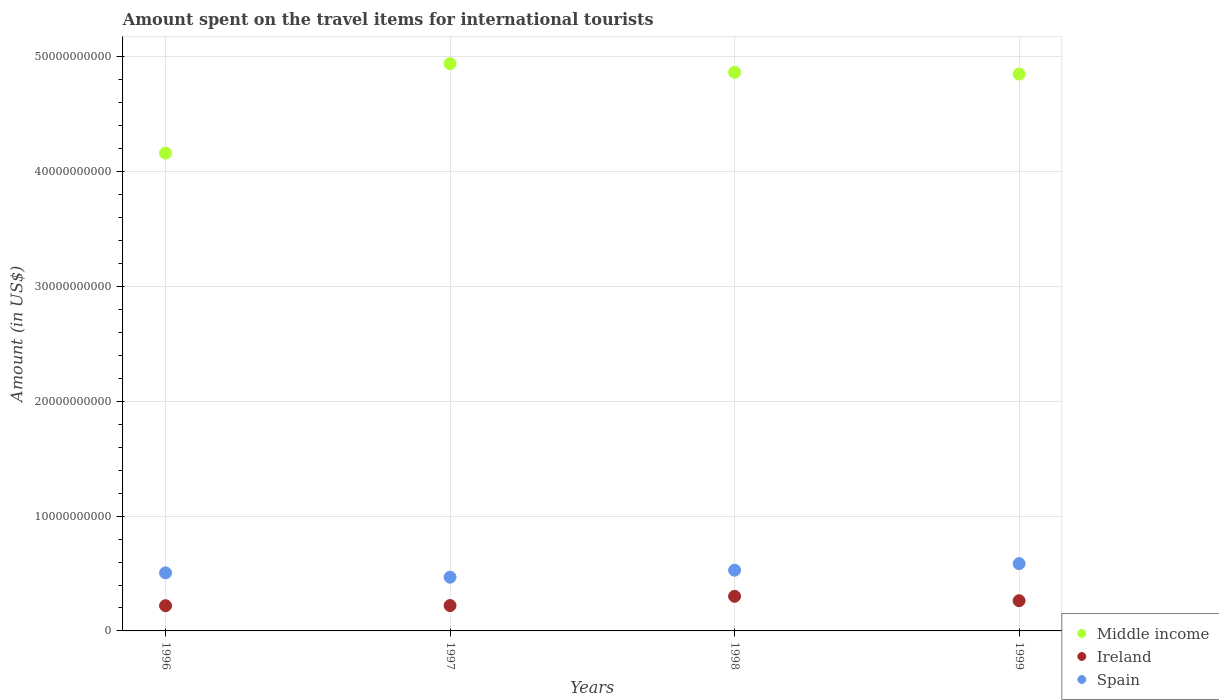What is the amount spent on the travel items for international tourists in Ireland in 1999?
Keep it short and to the point. 2.63e+09. Across all years, what is the maximum amount spent on the travel items for international tourists in Middle income?
Make the answer very short. 4.94e+1. Across all years, what is the minimum amount spent on the travel items for international tourists in Spain?
Give a very brief answer. 4.68e+09. In which year was the amount spent on the travel items for international tourists in Middle income maximum?
Give a very brief answer. 1997. In which year was the amount spent on the travel items for international tourists in Ireland minimum?
Offer a terse response. 1996. What is the total amount spent on the travel items for international tourists in Ireland in the graph?
Your answer should be compact. 1.01e+1. What is the difference between the amount spent on the travel items for international tourists in Ireland in 1997 and that in 1999?
Provide a succinct answer. -4.21e+08. What is the difference between the amount spent on the travel items for international tourists in Ireland in 1997 and the amount spent on the travel items for international tourists in Spain in 1999?
Your answer should be compact. -3.65e+09. What is the average amount spent on the travel items for international tourists in Spain per year?
Ensure brevity in your answer.  5.22e+09. In the year 1999, what is the difference between the amount spent on the travel items for international tourists in Middle income and amount spent on the travel items for international tourists in Spain?
Offer a terse response. 4.26e+1. In how many years, is the amount spent on the travel items for international tourists in Spain greater than 32000000000 US$?
Your response must be concise. 0. What is the ratio of the amount spent on the travel items for international tourists in Ireland in 1997 to that in 1998?
Your response must be concise. 0.73. Is the amount spent on the travel items for international tourists in Ireland in 1996 less than that in 1998?
Give a very brief answer. Yes. Is the difference between the amount spent on the travel items for international tourists in Middle income in 1997 and 1999 greater than the difference between the amount spent on the travel items for international tourists in Spain in 1997 and 1999?
Keep it short and to the point. Yes. What is the difference between the highest and the second highest amount spent on the travel items for international tourists in Spain?
Your answer should be compact. 5.74e+08. What is the difference between the highest and the lowest amount spent on the travel items for international tourists in Spain?
Keep it short and to the point. 1.18e+09. In how many years, is the amount spent on the travel items for international tourists in Middle income greater than the average amount spent on the travel items for international tourists in Middle income taken over all years?
Your answer should be compact. 3. How many years are there in the graph?
Provide a short and direct response. 4. What is the difference between two consecutive major ticks on the Y-axis?
Your answer should be very brief. 1.00e+1. Are the values on the major ticks of Y-axis written in scientific E-notation?
Your answer should be very brief. No. Does the graph contain any zero values?
Make the answer very short. No. Where does the legend appear in the graph?
Provide a short and direct response. Bottom right. How many legend labels are there?
Keep it short and to the point. 3. How are the legend labels stacked?
Your answer should be compact. Vertical. What is the title of the graph?
Keep it short and to the point. Amount spent on the travel items for international tourists. What is the label or title of the X-axis?
Offer a terse response. Years. What is the Amount (in US$) in Middle income in 1996?
Provide a succinct answer. 4.16e+1. What is the Amount (in US$) in Ireland in 1996?
Keep it short and to the point. 2.20e+09. What is the Amount (in US$) of Spain in 1996?
Make the answer very short. 5.06e+09. What is the Amount (in US$) of Middle income in 1997?
Make the answer very short. 4.94e+1. What is the Amount (in US$) of Ireland in 1997?
Your answer should be very brief. 2.21e+09. What is the Amount (in US$) of Spain in 1997?
Offer a terse response. 4.68e+09. What is the Amount (in US$) of Middle income in 1998?
Your response must be concise. 4.87e+1. What is the Amount (in US$) of Ireland in 1998?
Provide a succinct answer. 3.02e+09. What is the Amount (in US$) in Spain in 1998?
Your response must be concise. 5.29e+09. What is the Amount (in US$) of Middle income in 1999?
Your answer should be compact. 4.85e+1. What is the Amount (in US$) in Ireland in 1999?
Your answer should be compact. 2.63e+09. What is the Amount (in US$) of Spain in 1999?
Your answer should be compact. 5.86e+09. Across all years, what is the maximum Amount (in US$) of Middle income?
Give a very brief answer. 4.94e+1. Across all years, what is the maximum Amount (in US$) of Ireland?
Offer a terse response. 3.02e+09. Across all years, what is the maximum Amount (in US$) in Spain?
Provide a succinct answer. 5.86e+09. Across all years, what is the minimum Amount (in US$) in Middle income?
Your answer should be compact. 4.16e+1. Across all years, what is the minimum Amount (in US$) in Ireland?
Give a very brief answer. 2.20e+09. Across all years, what is the minimum Amount (in US$) in Spain?
Give a very brief answer. 4.68e+09. What is the total Amount (in US$) of Middle income in the graph?
Ensure brevity in your answer.  1.88e+11. What is the total Amount (in US$) in Ireland in the graph?
Make the answer very short. 1.01e+1. What is the total Amount (in US$) in Spain in the graph?
Keep it short and to the point. 2.09e+1. What is the difference between the Amount (in US$) in Middle income in 1996 and that in 1997?
Keep it short and to the point. -7.79e+09. What is the difference between the Amount (in US$) in Ireland in 1996 and that in 1997?
Provide a succinct answer. -1.20e+07. What is the difference between the Amount (in US$) of Spain in 1996 and that in 1997?
Offer a terse response. 3.76e+08. What is the difference between the Amount (in US$) in Middle income in 1996 and that in 1998?
Give a very brief answer. -7.04e+09. What is the difference between the Amount (in US$) of Ireland in 1996 and that in 1998?
Give a very brief answer. -8.17e+08. What is the difference between the Amount (in US$) in Spain in 1996 and that in 1998?
Provide a short and direct response. -2.31e+08. What is the difference between the Amount (in US$) in Middle income in 1996 and that in 1999?
Your answer should be compact. -6.88e+09. What is the difference between the Amount (in US$) in Ireland in 1996 and that in 1999?
Give a very brief answer. -4.33e+08. What is the difference between the Amount (in US$) of Spain in 1996 and that in 1999?
Your answer should be compact. -8.05e+08. What is the difference between the Amount (in US$) of Middle income in 1997 and that in 1998?
Your answer should be very brief. 7.52e+08. What is the difference between the Amount (in US$) in Ireland in 1997 and that in 1998?
Your response must be concise. -8.05e+08. What is the difference between the Amount (in US$) in Spain in 1997 and that in 1998?
Give a very brief answer. -6.07e+08. What is the difference between the Amount (in US$) in Middle income in 1997 and that in 1999?
Your answer should be very brief. 9.06e+08. What is the difference between the Amount (in US$) of Ireland in 1997 and that in 1999?
Provide a short and direct response. -4.21e+08. What is the difference between the Amount (in US$) in Spain in 1997 and that in 1999?
Your answer should be very brief. -1.18e+09. What is the difference between the Amount (in US$) in Middle income in 1998 and that in 1999?
Ensure brevity in your answer.  1.54e+08. What is the difference between the Amount (in US$) of Ireland in 1998 and that in 1999?
Your answer should be very brief. 3.84e+08. What is the difference between the Amount (in US$) in Spain in 1998 and that in 1999?
Give a very brief answer. -5.74e+08. What is the difference between the Amount (in US$) of Middle income in 1996 and the Amount (in US$) of Ireland in 1997?
Your answer should be compact. 3.94e+1. What is the difference between the Amount (in US$) of Middle income in 1996 and the Amount (in US$) of Spain in 1997?
Provide a short and direct response. 3.69e+1. What is the difference between the Amount (in US$) of Ireland in 1996 and the Amount (in US$) of Spain in 1997?
Your response must be concise. -2.48e+09. What is the difference between the Amount (in US$) in Middle income in 1996 and the Amount (in US$) in Ireland in 1998?
Offer a very short reply. 3.86e+1. What is the difference between the Amount (in US$) of Middle income in 1996 and the Amount (in US$) of Spain in 1998?
Make the answer very short. 3.63e+1. What is the difference between the Amount (in US$) in Ireland in 1996 and the Amount (in US$) in Spain in 1998?
Offer a terse response. -3.09e+09. What is the difference between the Amount (in US$) of Middle income in 1996 and the Amount (in US$) of Ireland in 1999?
Provide a succinct answer. 3.90e+1. What is the difference between the Amount (in US$) of Middle income in 1996 and the Amount (in US$) of Spain in 1999?
Make the answer very short. 3.58e+1. What is the difference between the Amount (in US$) of Ireland in 1996 and the Amount (in US$) of Spain in 1999?
Provide a short and direct response. -3.66e+09. What is the difference between the Amount (in US$) in Middle income in 1997 and the Amount (in US$) in Ireland in 1998?
Your response must be concise. 4.64e+1. What is the difference between the Amount (in US$) of Middle income in 1997 and the Amount (in US$) of Spain in 1998?
Offer a very short reply. 4.41e+1. What is the difference between the Amount (in US$) in Ireland in 1997 and the Amount (in US$) in Spain in 1998?
Make the answer very short. -3.08e+09. What is the difference between the Amount (in US$) in Middle income in 1997 and the Amount (in US$) in Ireland in 1999?
Your answer should be very brief. 4.68e+1. What is the difference between the Amount (in US$) of Middle income in 1997 and the Amount (in US$) of Spain in 1999?
Make the answer very short. 4.36e+1. What is the difference between the Amount (in US$) of Ireland in 1997 and the Amount (in US$) of Spain in 1999?
Provide a short and direct response. -3.65e+09. What is the difference between the Amount (in US$) in Middle income in 1998 and the Amount (in US$) in Ireland in 1999?
Offer a terse response. 4.60e+1. What is the difference between the Amount (in US$) in Middle income in 1998 and the Amount (in US$) in Spain in 1999?
Make the answer very short. 4.28e+1. What is the difference between the Amount (in US$) in Ireland in 1998 and the Amount (in US$) in Spain in 1999?
Your response must be concise. -2.85e+09. What is the average Amount (in US$) of Middle income per year?
Make the answer very short. 4.71e+1. What is the average Amount (in US$) in Ireland per year?
Offer a terse response. 2.51e+09. What is the average Amount (in US$) in Spain per year?
Keep it short and to the point. 5.22e+09. In the year 1996, what is the difference between the Amount (in US$) in Middle income and Amount (in US$) in Ireland?
Offer a very short reply. 3.94e+1. In the year 1996, what is the difference between the Amount (in US$) of Middle income and Amount (in US$) of Spain?
Your answer should be compact. 3.66e+1. In the year 1996, what is the difference between the Amount (in US$) in Ireland and Amount (in US$) in Spain?
Keep it short and to the point. -2.86e+09. In the year 1997, what is the difference between the Amount (in US$) in Middle income and Amount (in US$) in Ireland?
Keep it short and to the point. 4.72e+1. In the year 1997, what is the difference between the Amount (in US$) of Middle income and Amount (in US$) of Spain?
Your answer should be very brief. 4.47e+1. In the year 1997, what is the difference between the Amount (in US$) of Ireland and Amount (in US$) of Spain?
Provide a short and direct response. -2.47e+09. In the year 1998, what is the difference between the Amount (in US$) of Middle income and Amount (in US$) of Ireland?
Your response must be concise. 4.56e+1. In the year 1998, what is the difference between the Amount (in US$) in Middle income and Amount (in US$) in Spain?
Your answer should be very brief. 4.34e+1. In the year 1998, what is the difference between the Amount (in US$) of Ireland and Amount (in US$) of Spain?
Ensure brevity in your answer.  -2.27e+09. In the year 1999, what is the difference between the Amount (in US$) of Middle income and Amount (in US$) of Ireland?
Offer a terse response. 4.59e+1. In the year 1999, what is the difference between the Amount (in US$) in Middle income and Amount (in US$) in Spain?
Provide a succinct answer. 4.26e+1. In the year 1999, what is the difference between the Amount (in US$) in Ireland and Amount (in US$) in Spain?
Make the answer very short. -3.23e+09. What is the ratio of the Amount (in US$) in Middle income in 1996 to that in 1997?
Make the answer very short. 0.84. What is the ratio of the Amount (in US$) in Ireland in 1996 to that in 1997?
Make the answer very short. 0.99. What is the ratio of the Amount (in US$) of Spain in 1996 to that in 1997?
Your response must be concise. 1.08. What is the ratio of the Amount (in US$) of Middle income in 1996 to that in 1998?
Offer a terse response. 0.86. What is the ratio of the Amount (in US$) in Ireland in 1996 to that in 1998?
Your response must be concise. 0.73. What is the ratio of the Amount (in US$) of Spain in 1996 to that in 1998?
Keep it short and to the point. 0.96. What is the ratio of the Amount (in US$) of Middle income in 1996 to that in 1999?
Ensure brevity in your answer.  0.86. What is the ratio of the Amount (in US$) of Ireland in 1996 to that in 1999?
Offer a terse response. 0.84. What is the ratio of the Amount (in US$) of Spain in 1996 to that in 1999?
Your answer should be very brief. 0.86. What is the ratio of the Amount (in US$) in Middle income in 1997 to that in 1998?
Keep it short and to the point. 1.02. What is the ratio of the Amount (in US$) of Ireland in 1997 to that in 1998?
Offer a terse response. 0.73. What is the ratio of the Amount (in US$) in Spain in 1997 to that in 1998?
Provide a succinct answer. 0.89. What is the ratio of the Amount (in US$) in Middle income in 1997 to that in 1999?
Offer a terse response. 1.02. What is the ratio of the Amount (in US$) of Ireland in 1997 to that in 1999?
Ensure brevity in your answer.  0.84. What is the ratio of the Amount (in US$) in Spain in 1997 to that in 1999?
Provide a short and direct response. 0.8. What is the ratio of the Amount (in US$) in Ireland in 1998 to that in 1999?
Make the answer very short. 1.15. What is the ratio of the Amount (in US$) in Spain in 1998 to that in 1999?
Ensure brevity in your answer.  0.9. What is the difference between the highest and the second highest Amount (in US$) in Middle income?
Your answer should be compact. 7.52e+08. What is the difference between the highest and the second highest Amount (in US$) in Ireland?
Provide a succinct answer. 3.84e+08. What is the difference between the highest and the second highest Amount (in US$) in Spain?
Offer a terse response. 5.74e+08. What is the difference between the highest and the lowest Amount (in US$) of Middle income?
Your response must be concise. 7.79e+09. What is the difference between the highest and the lowest Amount (in US$) of Ireland?
Offer a very short reply. 8.17e+08. What is the difference between the highest and the lowest Amount (in US$) in Spain?
Offer a very short reply. 1.18e+09. 